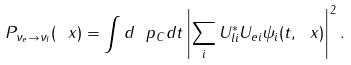Convert formula to latex. <formula><loc_0><loc_0><loc_500><loc_500>P _ { \nu _ { e } \rightarrow \nu _ { l } } ( \ x ) = \int d \ p _ { C } d t \left | \sum _ { i } U _ { l i } ^ { * } U _ { e i } \psi _ { i } ( t , \ x ) \right | ^ { 2 } .</formula> 